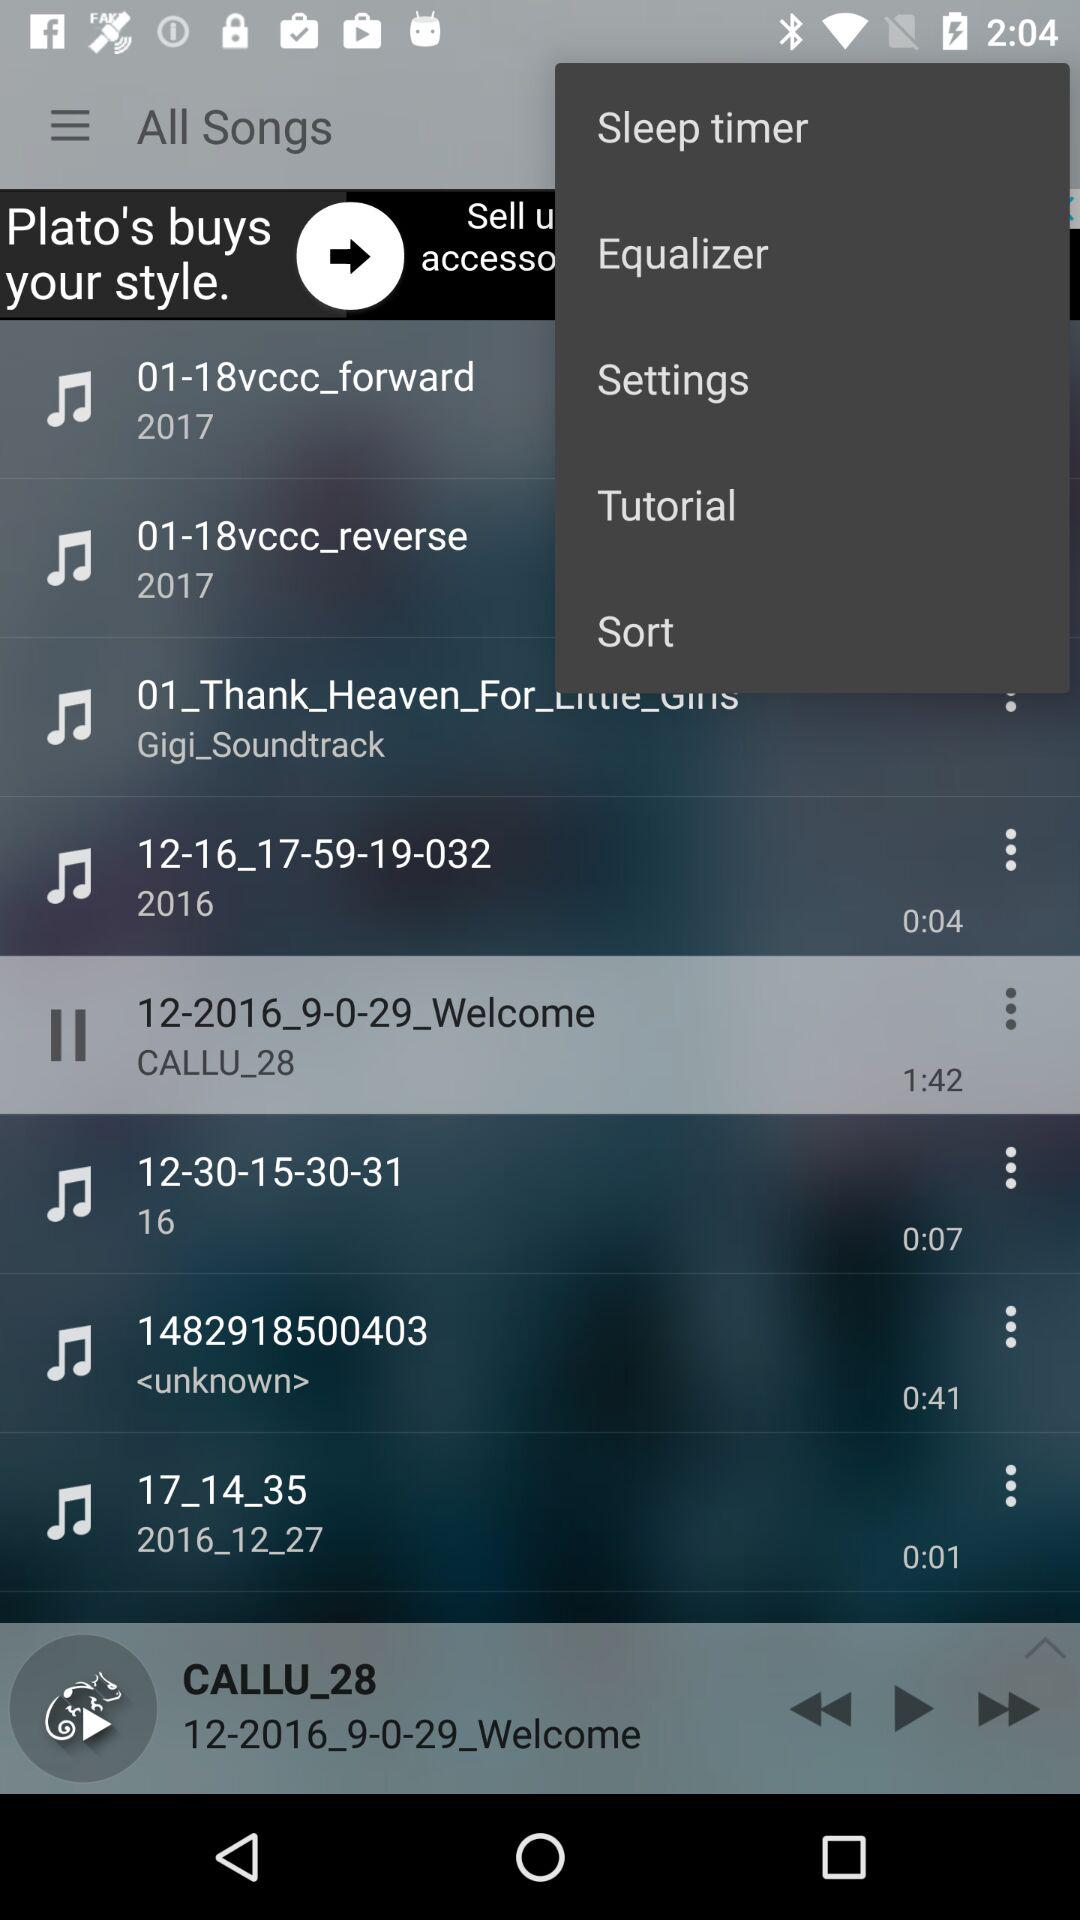What is the time duration of the currently playing song? The time duration of the song is 1 minute and 42 seconds. 